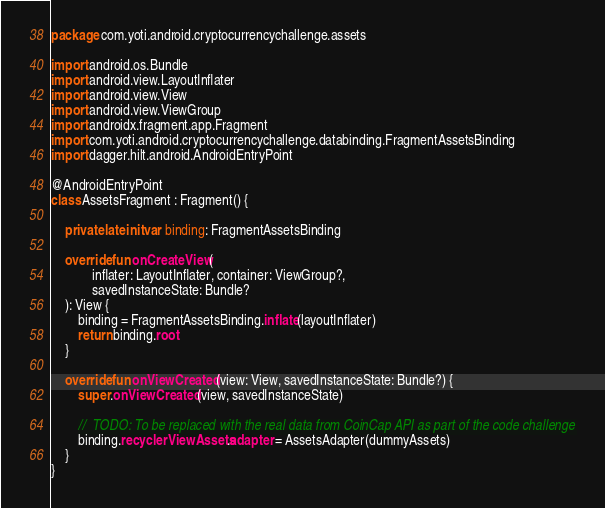<code> <loc_0><loc_0><loc_500><loc_500><_Kotlin_>package com.yoti.android.cryptocurrencychallenge.assets

import android.os.Bundle
import android.view.LayoutInflater
import android.view.View
import android.view.ViewGroup
import androidx.fragment.app.Fragment
import com.yoti.android.cryptocurrencychallenge.databinding.FragmentAssetsBinding
import dagger.hilt.android.AndroidEntryPoint

@AndroidEntryPoint
class AssetsFragment : Fragment() {

    private lateinit var binding: FragmentAssetsBinding

    override fun onCreateView(
            inflater: LayoutInflater, container: ViewGroup?,
            savedInstanceState: Bundle?
    ): View {
        binding = FragmentAssetsBinding.inflate(layoutInflater)
        return binding.root
    }

    override fun onViewCreated(view: View, savedInstanceState: Bundle?) {
        super.onViewCreated(view, savedInstanceState)

        //  TODO: To be replaced with the real data from CoinCap API as part of the code challenge
        binding.recyclerViewAssets.adapter = AssetsAdapter(dummyAssets)
    }
}</code> 